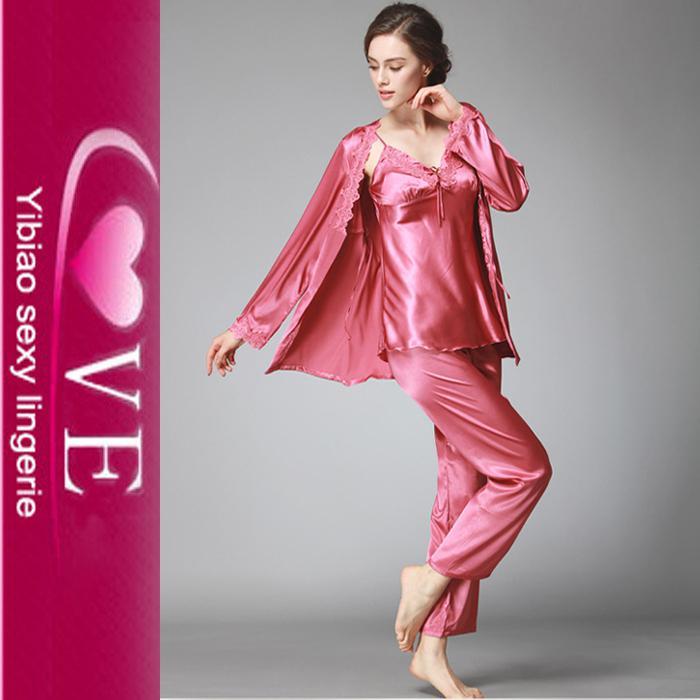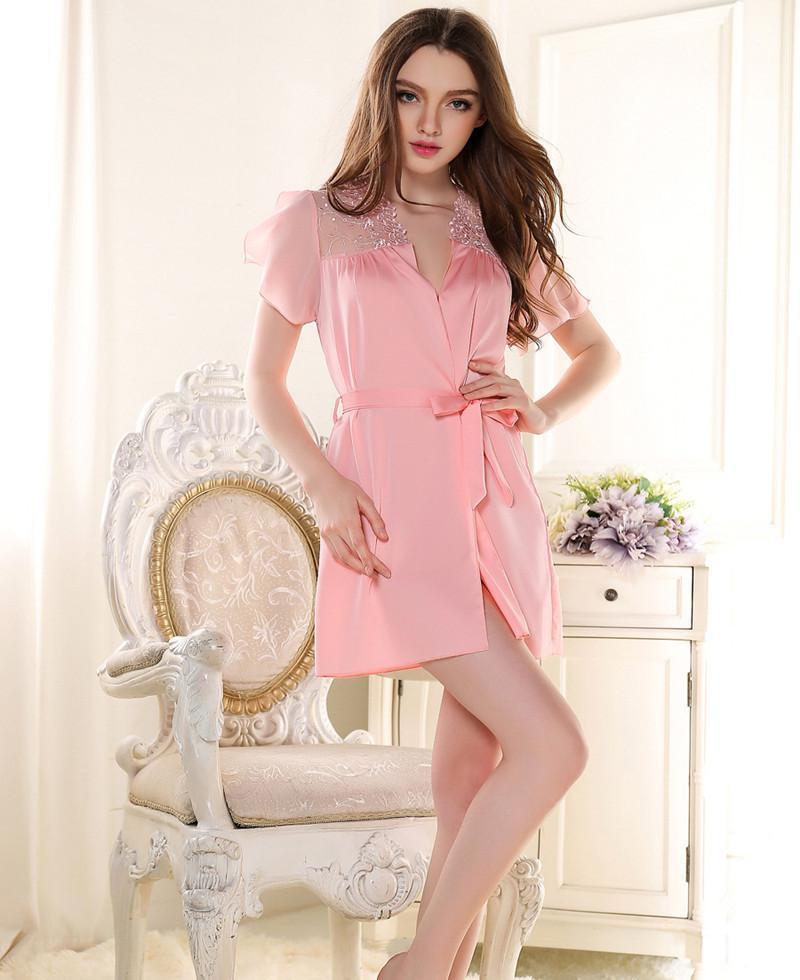The first image is the image on the left, the second image is the image on the right. Given the left and right images, does the statement "A pajama set worn by a woman in one image is made with a silky fabric with button-down long sleeve shirt, with cuffs on both the shirt sleeves and pant legs." hold true? Answer yes or no. No. The first image is the image on the left, the second image is the image on the right. Evaluate the accuracy of this statement regarding the images: "One image shows a model wearing a sleeved open-front top over a lace-trimmed garment with spaghetti straps.". Is it true? Answer yes or no. Yes. 